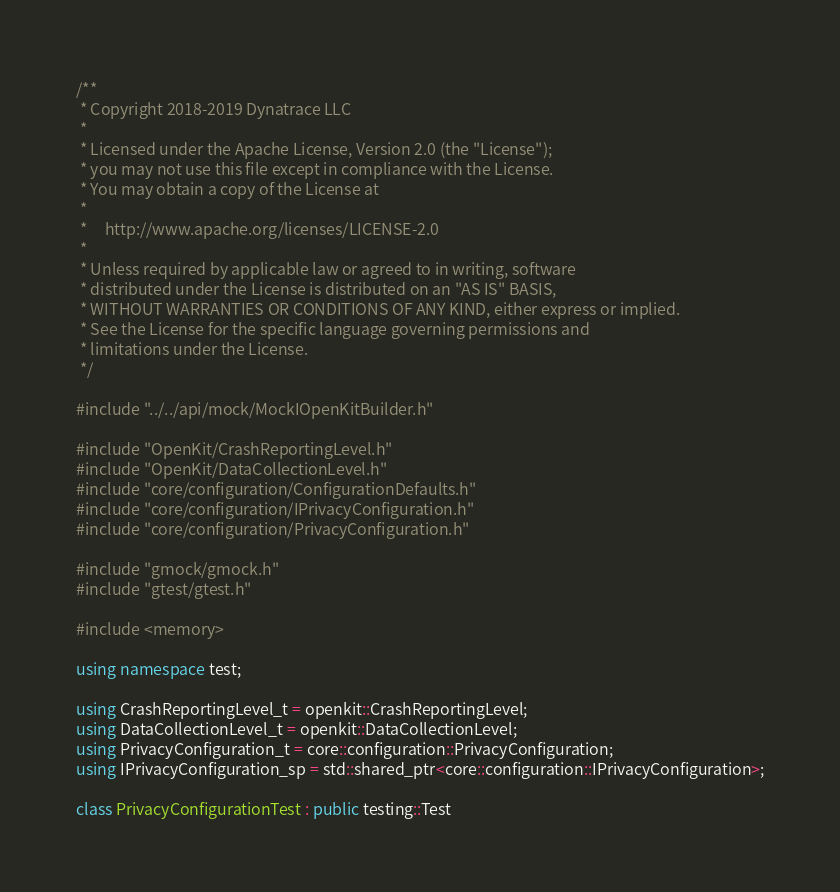Convert code to text. <code><loc_0><loc_0><loc_500><loc_500><_C++_>/**
 * Copyright 2018-2019 Dynatrace LLC
 *
 * Licensed under the Apache License, Version 2.0 (the "License");
 * you may not use this file except in compliance with the License.
 * You may obtain a copy of the License at
 *
 *     http://www.apache.org/licenses/LICENSE-2.0
 *
 * Unless required by applicable law or agreed to in writing, software
 * distributed under the License is distributed on an "AS IS" BASIS,
 * WITHOUT WARRANTIES OR CONDITIONS OF ANY KIND, either express or implied.
 * See the License for the specific language governing permissions and
 * limitations under the License.
 */

#include "../../api/mock/MockIOpenKitBuilder.h"

#include "OpenKit/CrashReportingLevel.h"
#include "OpenKit/DataCollectionLevel.h"
#include "core/configuration/ConfigurationDefaults.h"
#include "core/configuration/IPrivacyConfiguration.h"
#include "core/configuration/PrivacyConfiguration.h"

#include "gmock/gmock.h"
#include "gtest/gtest.h"

#include <memory>

using namespace test;

using CrashReportingLevel_t = openkit::CrashReportingLevel;
using DataCollectionLevel_t = openkit::DataCollectionLevel;
using PrivacyConfiguration_t = core::configuration::PrivacyConfiguration;
using IPrivacyConfiguration_sp = std::shared_ptr<core::configuration::IPrivacyConfiguration>;

class PrivacyConfigurationTest : public testing::Test</code> 